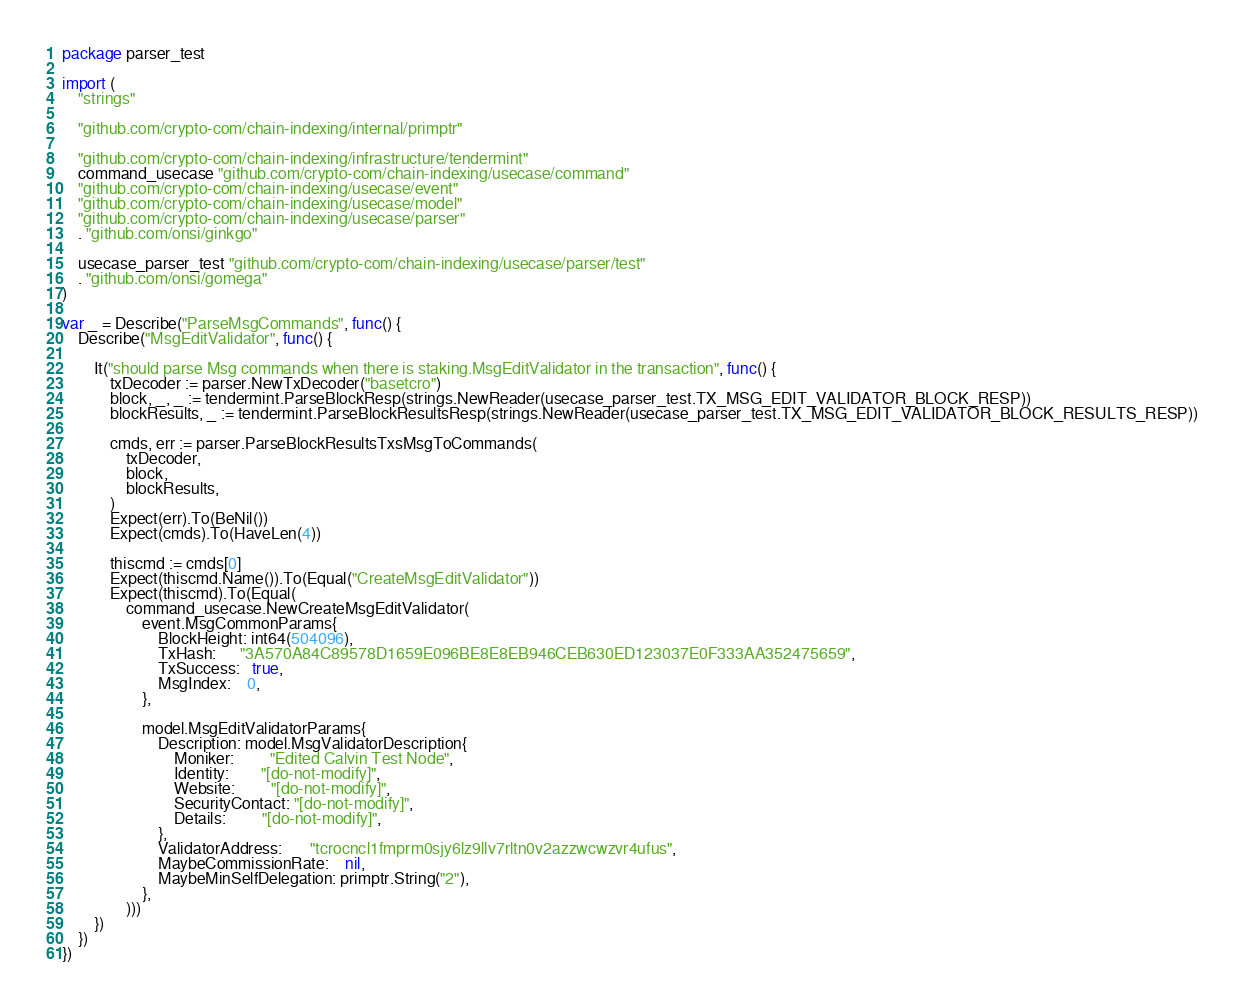<code> <loc_0><loc_0><loc_500><loc_500><_Go_>package parser_test

import (
	"strings"

	"github.com/crypto-com/chain-indexing/internal/primptr"

	"github.com/crypto-com/chain-indexing/infrastructure/tendermint"
	command_usecase "github.com/crypto-com/chain-indexing/usecase/command"
	"github.com/crypto-com/chain-indexing/usecase/event"
	"github.com/crypto-com/chain-indexing/usecase/model"
	"github.com/crypto-com/chain-indexing/usecase/parser"
	. "github.com/onsi/ginkgo"

	usecase_parser_test "github.com/crypto-com/chain-indexing/usecase/parser/test"
	. "github.com/onsi/gomega"
)

var _ = Describe("ParseMsgCommands", func() {
	Describe("MsgEditValidator", func() {

		It("should parse Msg commands when there is staking.MsgEditValidator in the transaction", func() {
			txDecoder := parser.NewTxDecoder("basetcro")
			block, _, _ := tendermint.ParseBlockResp(strings.NewReader(usecase_parser_test.TX_MSG_EDIT_VALIDATOR_BLOCK_RESP))
			blockResults, _ := tendermint.ParseBlockResultsResp(strings.NewReader(usecase_parser_test.TX_MSG_EDIT_VALIDATOR_BLOCK_RESULTS_RESP))

			cmds, err := parser.ParseBlockResultsTxsMsgToCommands(
				txDecoder,
				block,
				blockResults,
			)
			Expect(err).To(BeNil())
			Expect(cmds).To(HaveLen(4))

			thiscmd := cmds[0]
			Expect(thiscmd.Name()).To(Equal("CreateMsgEditValidator"))
			Expect(thiscmd).To(Equal(
				command_usecase.NewCreateMsgEditValidator(
					event.MsgCommonParams{
						BlockHeight: int64(504096),
						TxHash:      "3A570A84C89578D1659E096BE8E8EB946CEB630ED123037E0F333AA352475659",
						TxSuccess:   true,
						MsgIndex:    0,
					},

					model.MsgEditValidatorParams{
						Description: model.MsgValidatorDescription{
							Moniker:         "Edited Calvin Test Node",
							Identity:        "[do-not-modify]",
							Website:         "[do-not-modify]",
							SecurityContact: "[do-not-modify]",
							Details:         "[do-not-modify]",
						},
						ValidatorAddress:       "tcrocncl1fmprm0sjy6lz9llv7rltn0v2azzwcwzvr4ufus",
						MaybeCommissionRate:    nil,
						MaybeMinSelfDelegation: primptr.String("2"),
					},
				)))
		})
	})
})
</code> 